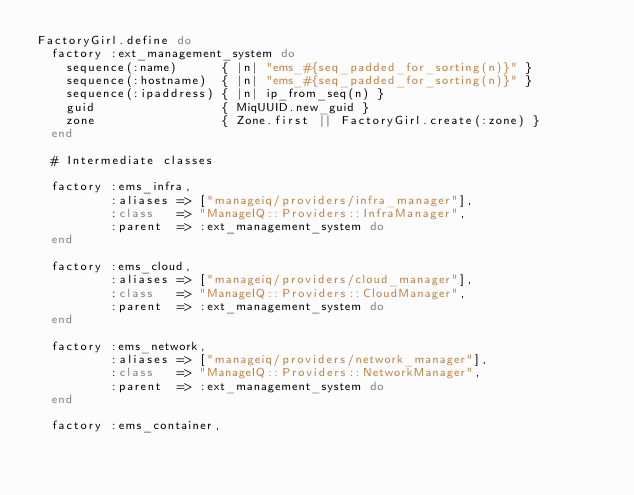<code> <loc_0><loc_0><loc_500><loc_500><_Ruby_>FactoryGirl.define do
  factory :ext_management_system do
    sequence(:name)      { |n| "ems_#{seq_padded_for_sorting(n)}" }
    sequence(:hostname)  { |n| "ems_#{seq_padded_for_sorting(n)}" }
    sequence(:ipaddress) { |n| ip_from_seq(n) }
    guid                 { MiqUUID.new_guid }
    zone                 { Zone.first || FactoryGirl.create(:zone) }
  end

  # Intermediate classes

  factory :ems_infra,
          :aliases => ["manageiq/providers/infra_manager"],
          :class   => "ManageIQ::Providers::InfraManager",
          :parent  => :ext_management_system do
  end

  factory :ems_cloud,
          :aliases => ["manageiq/providers/cloud_manager"],
          :class   => "ManageIQ::Providers::CloudManager",
          :parent  => :ext_management_system do
  end

  factory :ems_network,
          :aliases => ["manageiq/providers/network_manager"],
          :class   => "ManageIQ::Providers::NetworkManager",
          :parent  => :ext_management_system do
  end

  factory :ems_container,</code> 